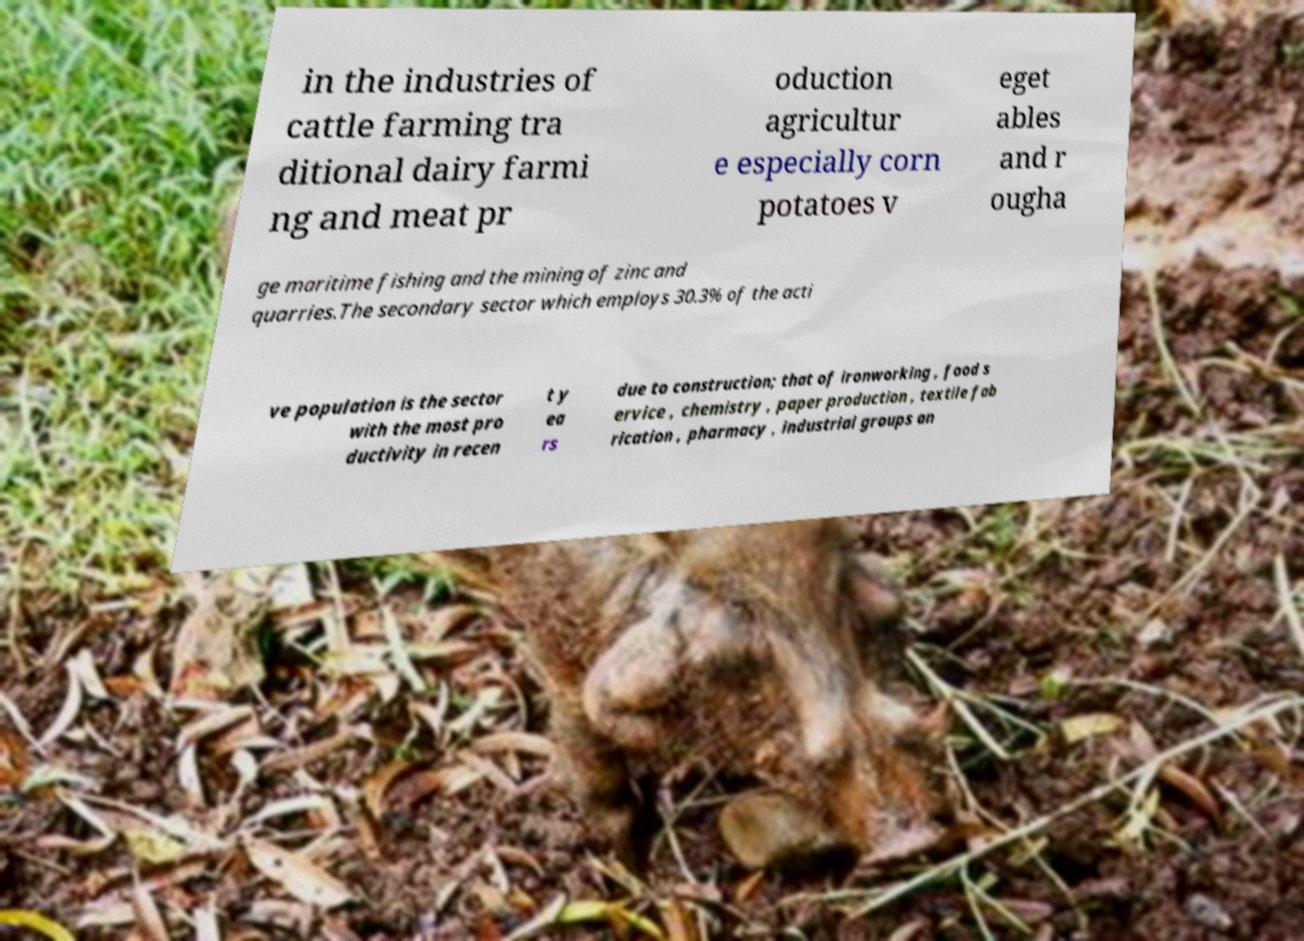Could you assist in decoding the text presented in this image and type it out clearly? in the industries of cattle farming tra ditional dairy farmi ng and meat pr oduction agricultur e especially corn potatoes v eget ables and r ougha ge maritime fishing and the mining of zinc and quarries.The secondary sector which employs 30.3% of the acti ve population is the sector with the most pro ductivity in recen t y ea rs due to construction; that of ironworking , food s ervice , chemistry , paper production , textile fab rication , pharmacy , industrial groups an 